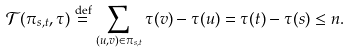<formula> <loc_0><loc_0><loc_500><loc_500>\mathcal { T } ( \pi _ { s , t } , \tau ) \stackrel { \text {def} } { = } \sum _ { ( u , v ) \in \pi _ { s , t } } \tau ( v ) - \tau ( u ) = \tau ( t ) - \tau ( s ) \leq n .</formula> 